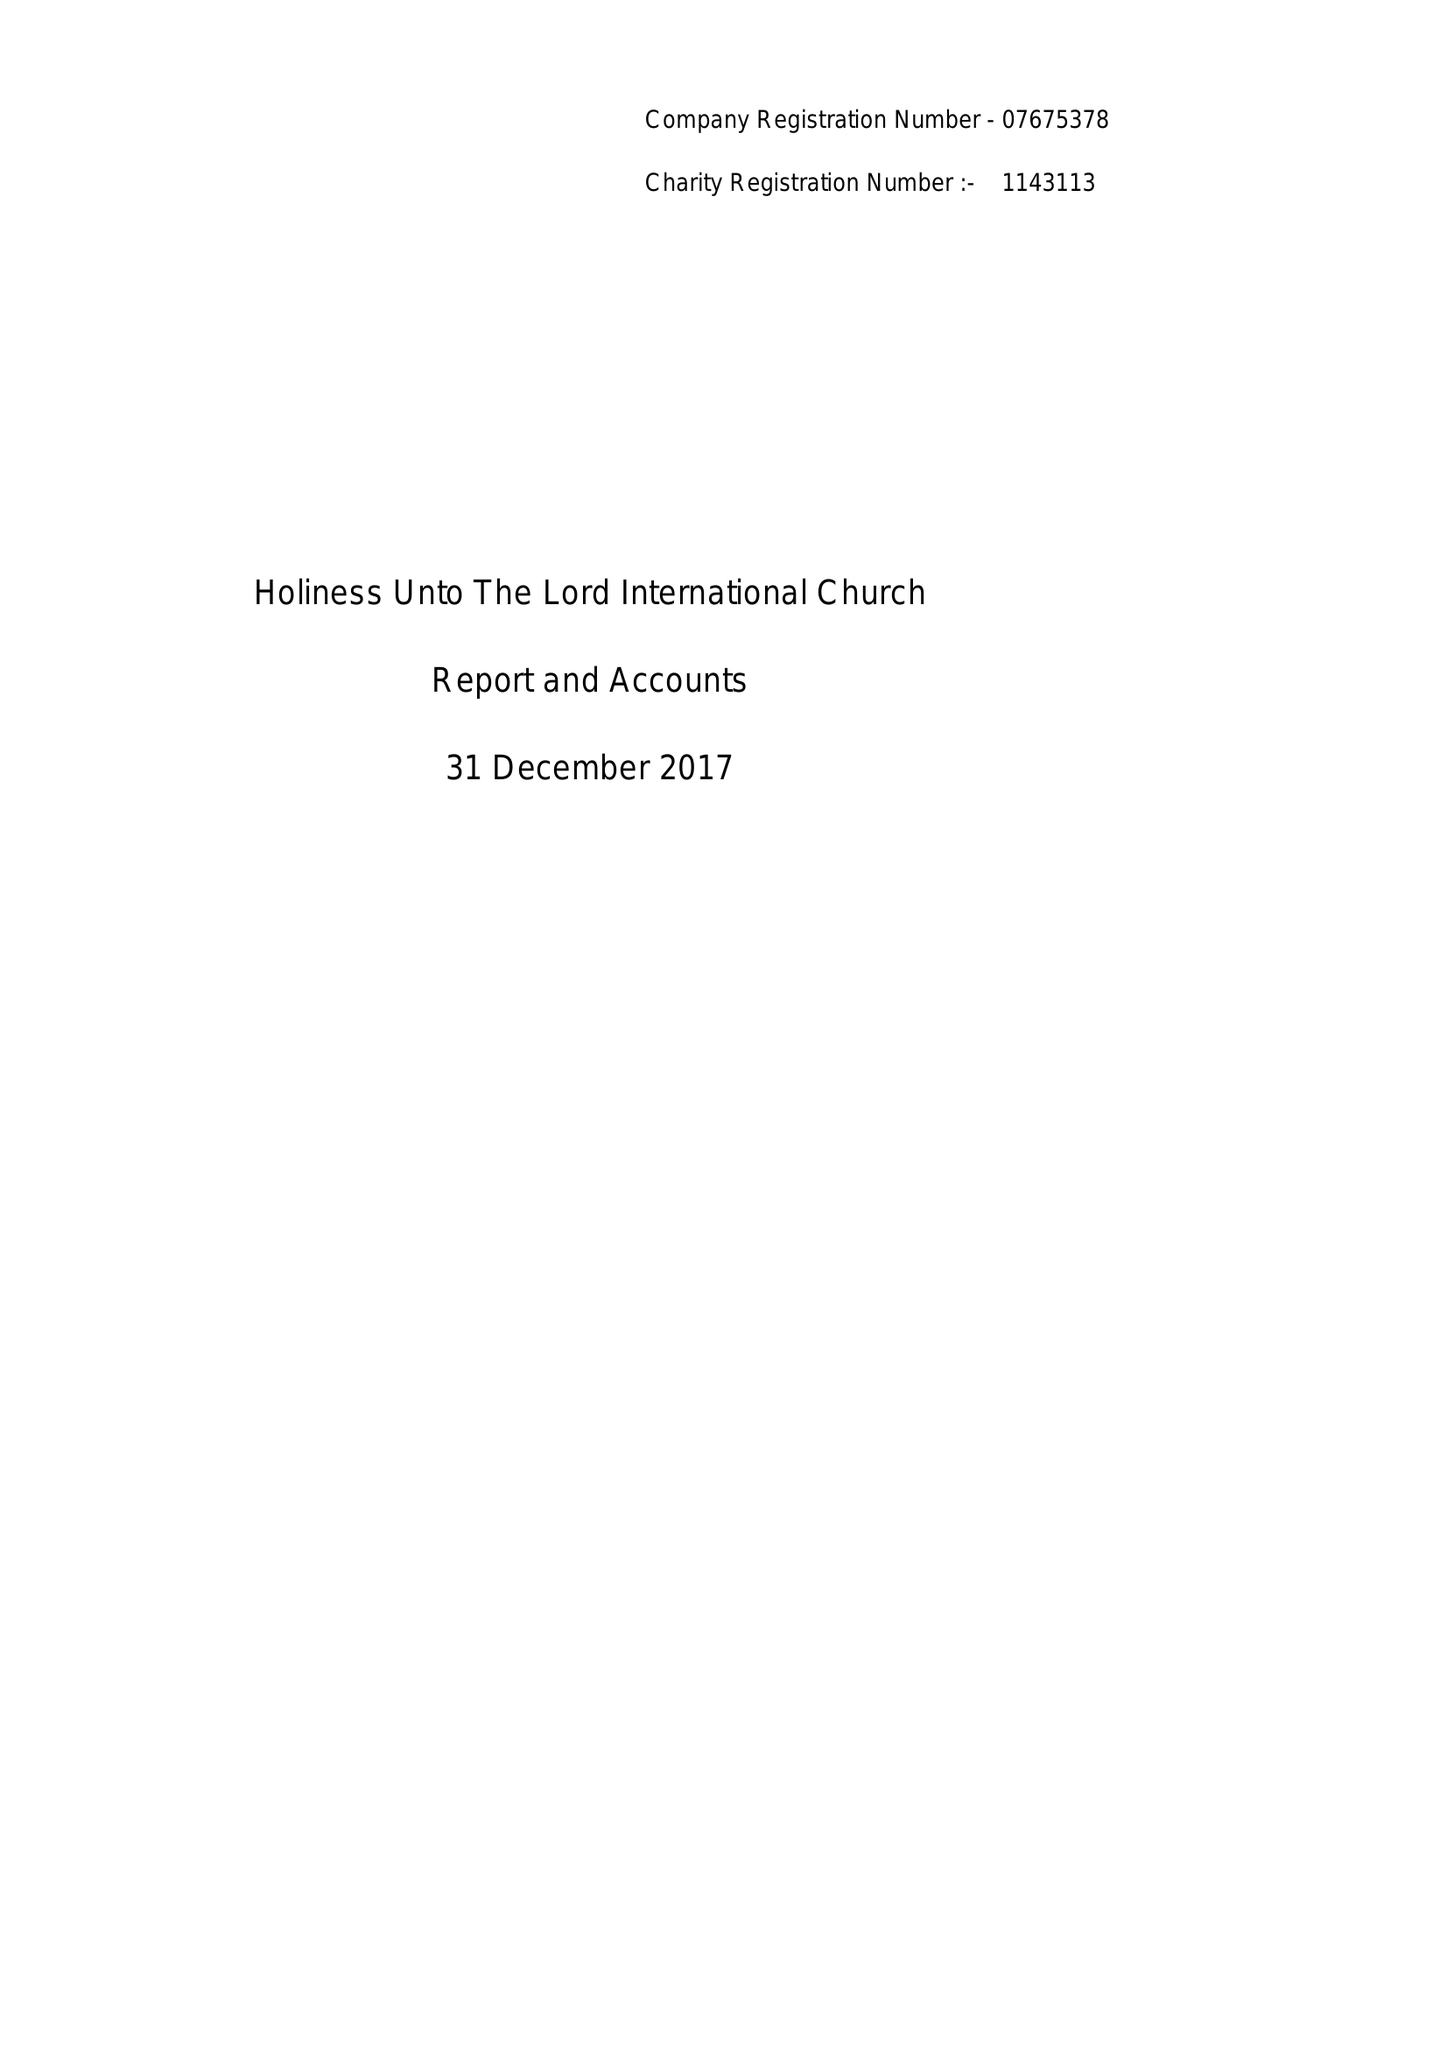What is the value for the report_date?
Answer the question using a single word or phrase. 2017-12-31 